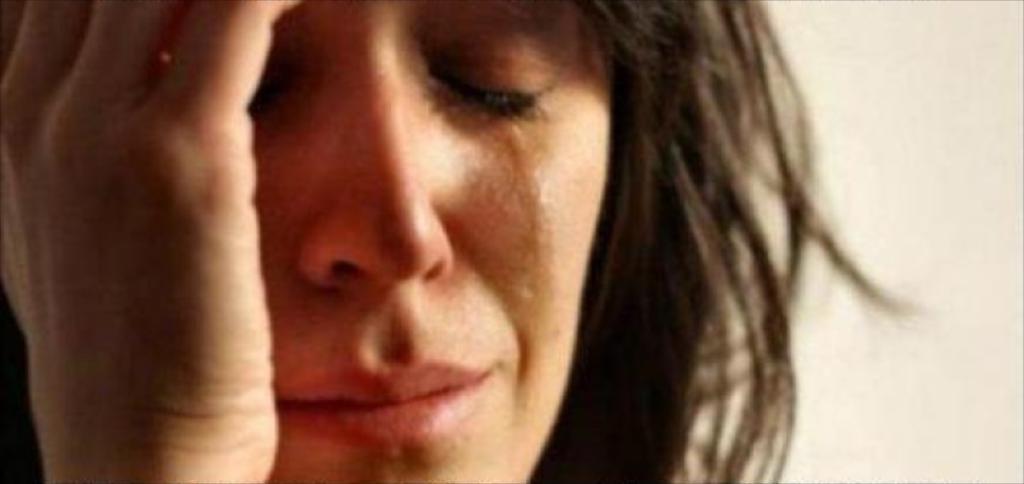Please provide a concise description of this image. In this image, we can see a person and the background. 